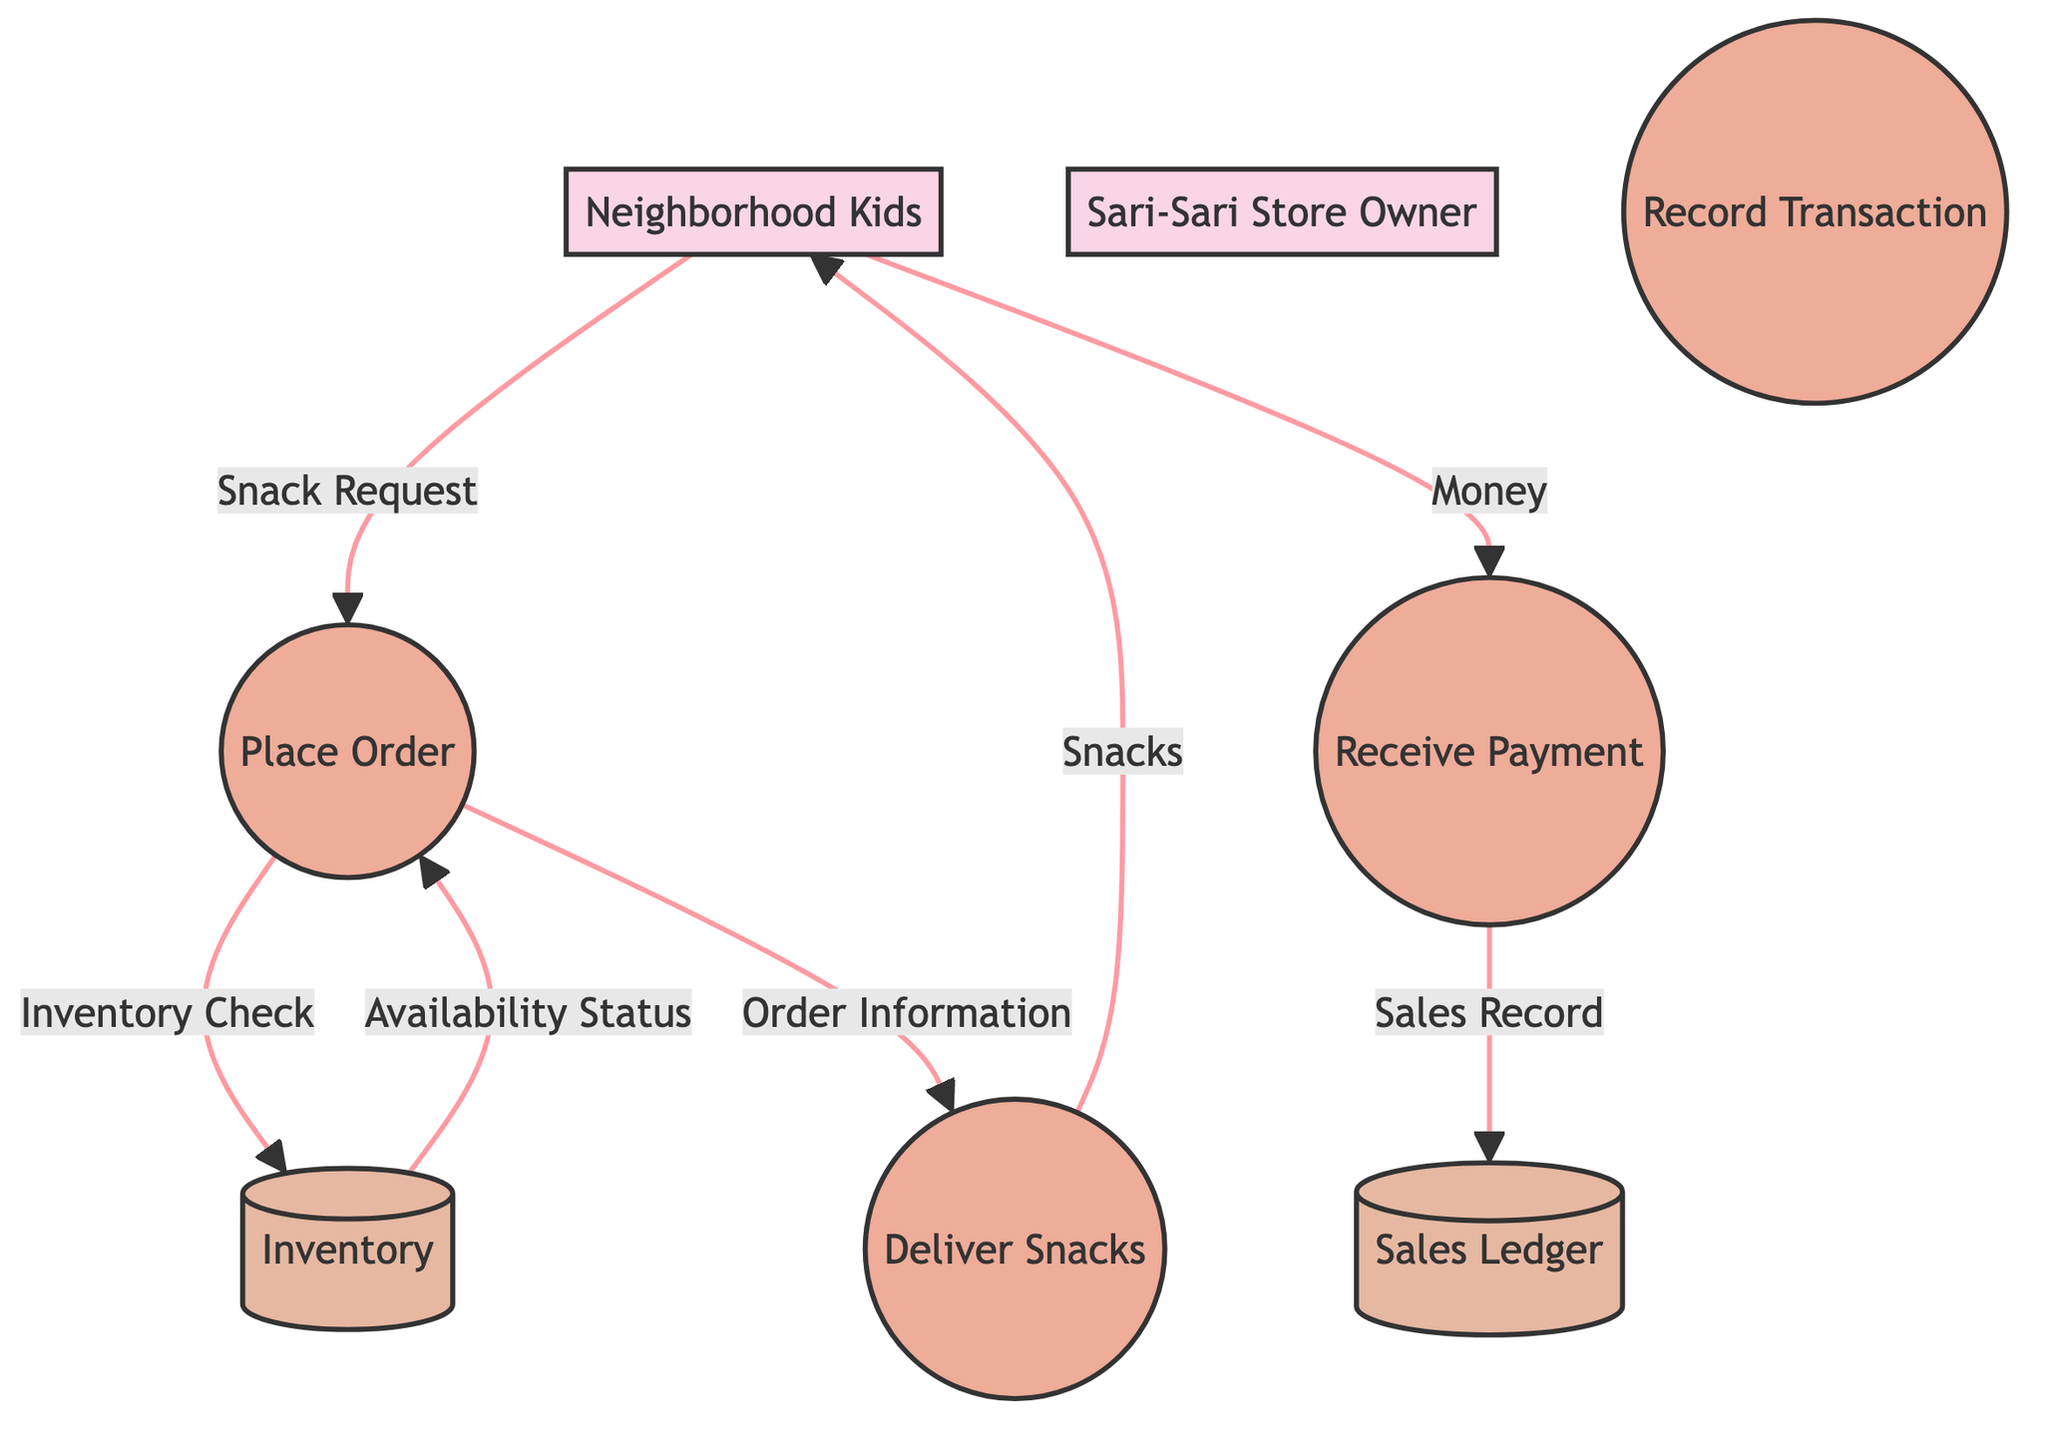How many external entities are in the diagram? The diagram includes two external entities: Neighborhood Kids and Sari-Sari Store Owner. This information is found by counting the external entities section in the diagram.
Answer: 2 What is the first process that occurs in the transactions? The first process in the transactions is "Place Order," where the kids request the snacks they want. This can be identified by examining the flow from the Neighborhood Kids to the Place Order process.
Answer: Place Order Which data store records sales transactions? The "Sales Ledger" is responsible for recording all sales transactions. This is indicated in the data stores section of the diagram where the process "Receive Payment" sends data to it for record-keeping.
Answer: Sales Ledger What is the output of the "Deliver Snacks" process? The output of the "Deliver Snacks" process is "Snacks," which are provided to the kids after the transaction is completed. This can be seen in the flow from the Deliver Snacks process to the Neighborhood Kids.
Answer: Snacks What link connects the "Place Order" and "Inventory" processes? The link connecting "Place Order" and "Inventory" is "Inventory Check," where the system checks the requested snacks' availability. This can be found by looking at the arrows indicating the flow of information between these two processes.
Answer: Inventory Check What is the purpose of the "Record Transaction" process? The "Record Transaction" process is intended for bookkeeping, capturing details of the sales and payments received. This is noted in the description of the process itself in the diagram, highlighting its role in maintaining financial records.
Answer: Bookkeeping Which external entity provides money to the sari-sari store? The "Neighborhood Kids" provide money as payment to the sari-sari store during the transaction process. This can be determined by following the data flow directed from the kids to the Receive Payment process.
Answer: Neighborhood Kids How many processes are described in the diagram? There are four processes described in the diagram: Place Order, Receive Payment, Deliver Snacks, and Record Transaction. This is determined by counting the processes listed in the processes section of the diagram.
Answer: 4 What do the Neighborhood Kids do before receiving snacks? Before receiving snacks, the Neighborhood Kids "Place Order," which includes requesting the specific snacks they want. This sequence can be traced through the flow from the Neighborhood Kids to the Place Order process.
Answer: Place Order 